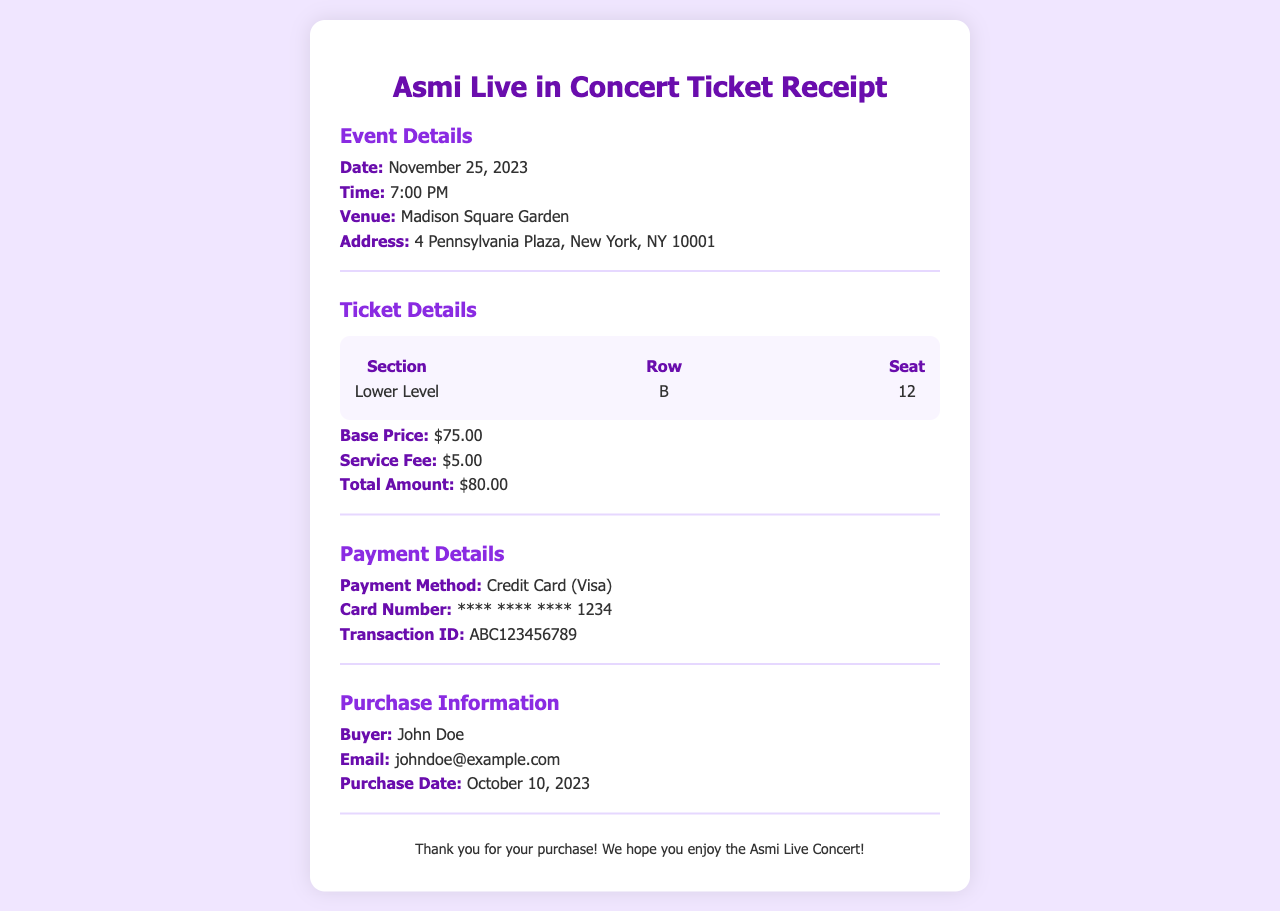What is the date of the concert? The date of the concert is specifically mentioned in the document under event details.
Answer: November 25, 2023 Where is the concert taking place? The venue for the concert is clearly stated in the event details section.
Answer: Madison Square Garden What is the seat number? The seat number is listed under ticket details and specifies the exact seat assigned.
Answer: 12 What is the transaction ID? The transaction ID is included in the payment details and is a unique identifier for the transaction.
Answer: ABC123456789 What is the total amount paid for the ticket? The total amount is mentioned under ticket details, adding the base price and service fee.
Answer: $80.00 Who is the buyer of the ticket? The buyer's name is specified in the purchase information section of the document.
Answer: John Doe What is the payment method used? The payment method is provided in the payment details, indicating how the transaction was processed.
Answer: Credit Card (Visa) What is the service fee for the ticket? The service fee amount is explicitly stated in the ticket details section.
Answer: $5.00 When was the ticket purchased? The purchase date is mentioned in the purchase information section, indicating when the transaction occurred.
Answer: October 10, 2023 